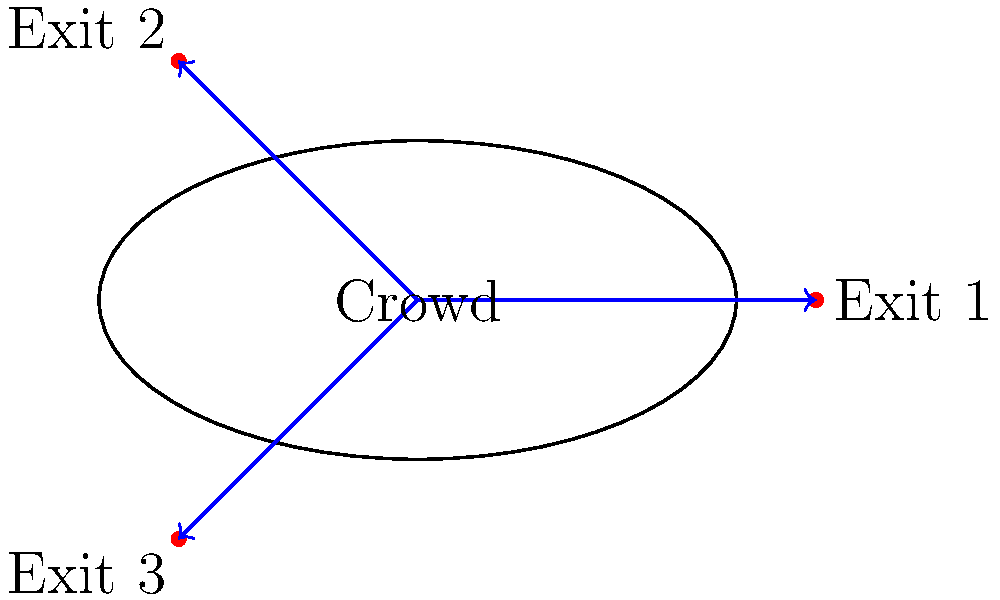During a large public gathering in a city square, you observe a crowd of approximately 1000 people. Three exit points are available: Exit 1 to the east, Exit 2 to the northwest, and Exit 3 to the southwest. Based on your training and the crowd's behavior, you estimate that 50% will move towards Exit 1, 30% towards Exit 2, and 20% towards Exit 3. What is the magnitude of the resultant crowd movement vector if we assume each individual contributes a unit vector in their chosen direction? To solve this problem, we'll follow these steps:

1) First, let's assign unit vectors to each exit:
   Exit 1 (east): $\vec{i} = (1, 0)$
   Exit 2 (northwest): $\vec{j} = (-\frac{\sqrt{2}}{2}, \frac{\sqrt{2}}{2})$
   Exit 3 (southwest): $\vec{k} = (-\frac{\sqrt{2}}{2}, -\frac{\sqrt{2}}{2})$

2) Now, we'll calculate the contribution of each group:
   Exit 1: $500 \cdot (1, 0) = (500, 0)$
   Exit 2: $300 \cdot (-\frac{\sqrt{2}}{2}, \frac{\sqrt{2}}{2}) = (-150\sqrt{2}, 150\sqrt{2})$
   Exit 3: $200 \cdot (-\frac{\sqrt{2}}{2}, -\frac{\sqrt{2}}{2}) = (-100\sqrt{2}, -100\sqrt{2})$

3) Sum these vectors to get the resultant:
   $\vec{R} = (500, 0) + (-150\sqrt{2}, 150\sqrt{2}) + (-100\sqrt{2}, -100\sqrt{2})$
   $\vec{R} = (500 - 250\sqrt{2}, 50\sqrt{2})$

4) Calculate the magnitude of this resultant vector:
   $|\vec{R}| = \sqrt{(500 - 250\sqrt{2})^2 + (50\sqrt{2})^2}$

5) Simplify:
   $|\vec{R}| = \sqrt{250000 - 250000\sqrt{2} + 31250(2) + 5000}$
   $|\vec{R}| = \sqrt{286250 - 250000\sqrt{2}}$

6) This can be further simplified to:
   $|\vec{R}| = 10\sqrt{2862.5 - 2500\sqrt{2}}$
Answer: $10\sqrt{2862.5 - 2500\sqrt{2}}$ 